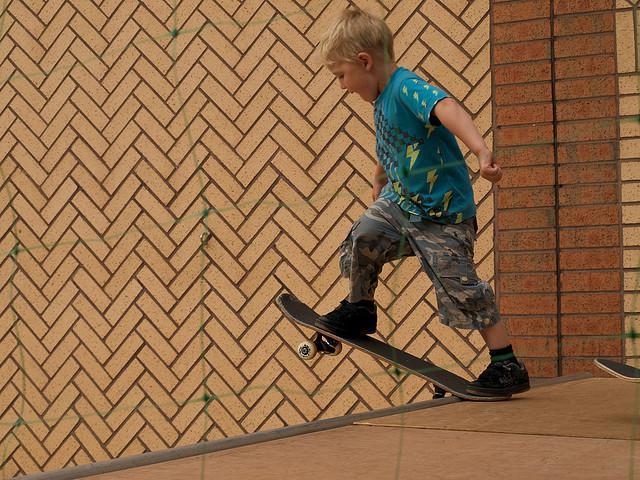How many birds do you see?
Give a very brief answer. 0. 